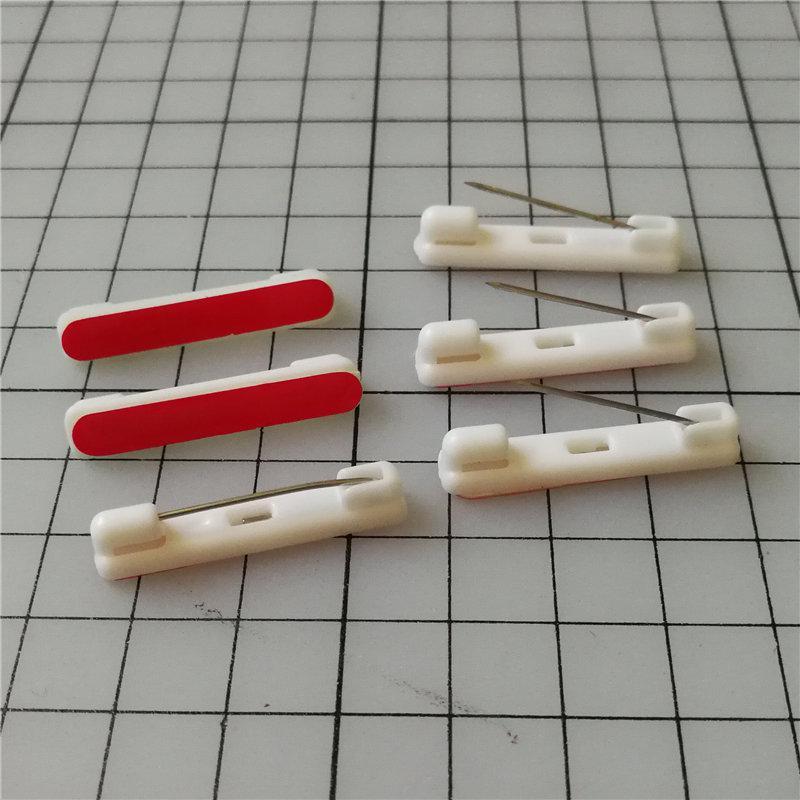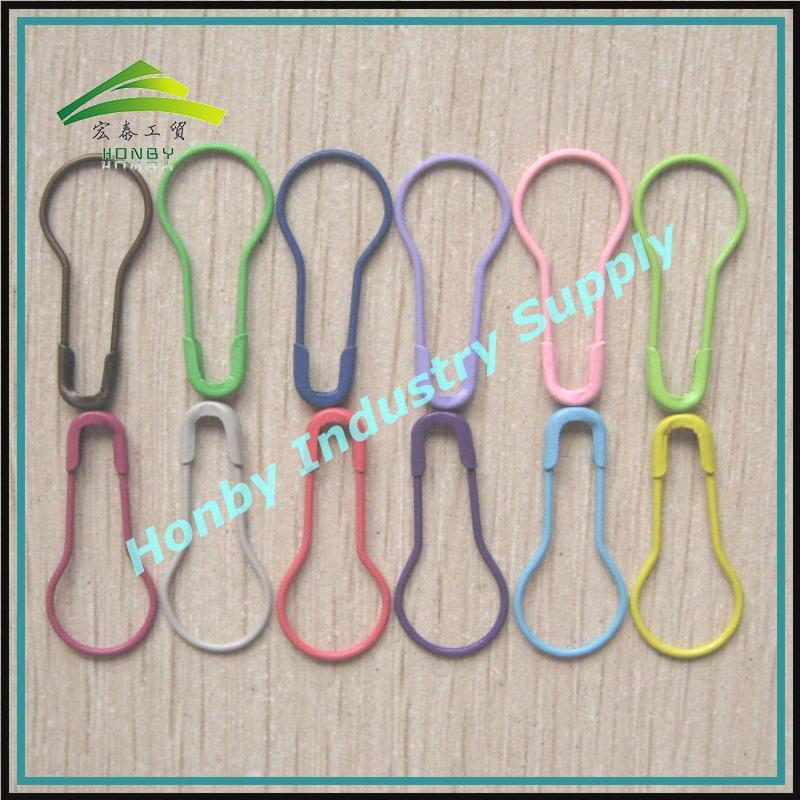The first image is the image on the left, the second image is the image on the right. Examine the images to the left and right. Is the description "One image contains exactly two gold-colored safety pins displayed horizontally." accurate? Answer yes or no. No. The first image is the image on the left, the second image is the image on the right. For the images shown, is this caption "The safety pins have numbers on them." true? Answer yes or no. No. 